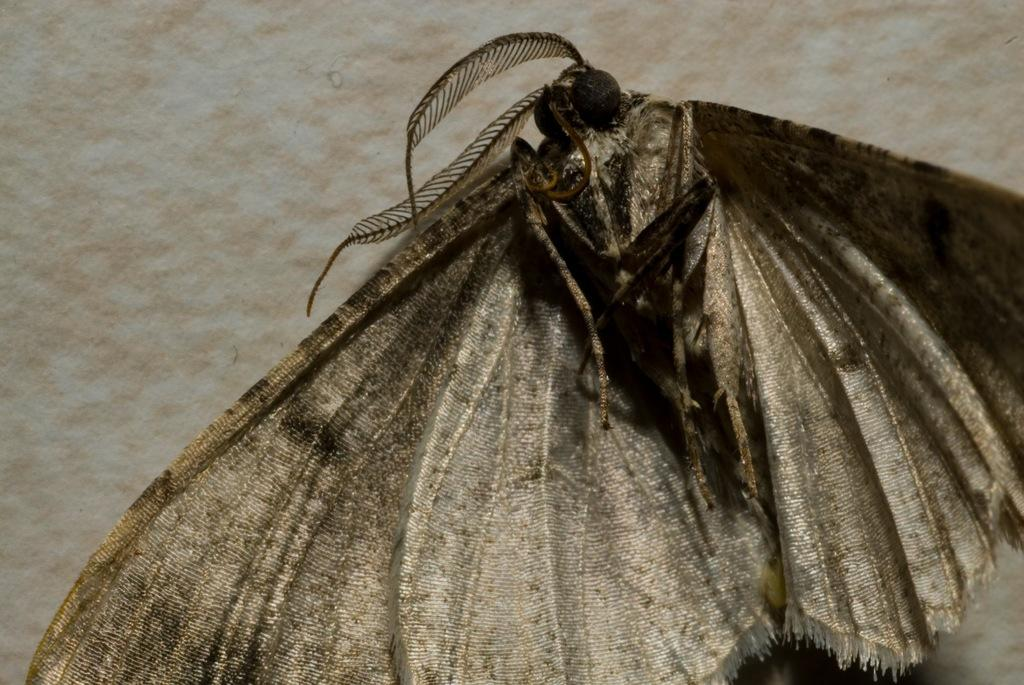What type of creature can be seen in the image? There is an insect in the image. What is the background or surface on which the insect is located? The insect is on a white surface. What type of government is depicted in the image? There is no depiction of a government in the image; it features an insect on a white surface. 